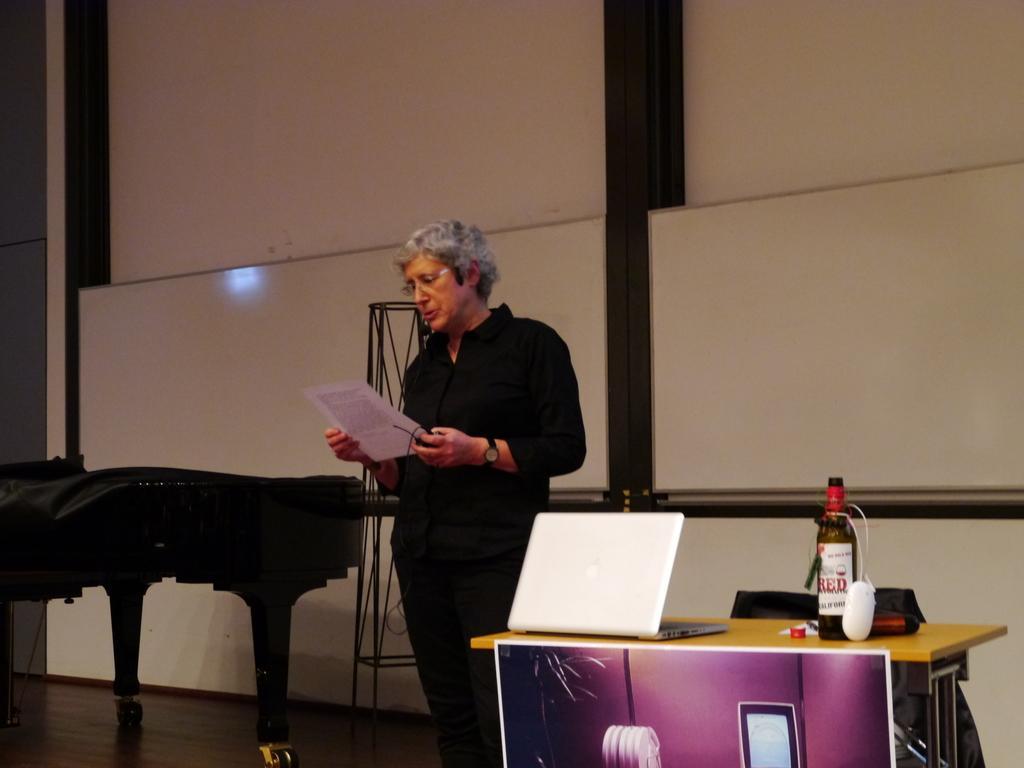How would you summarize this image in a sentence or two? Here we can see one woman standing and reading something on a paper which is in her hands. Here we can see one table and on the table we can see a bottle, laptop. 